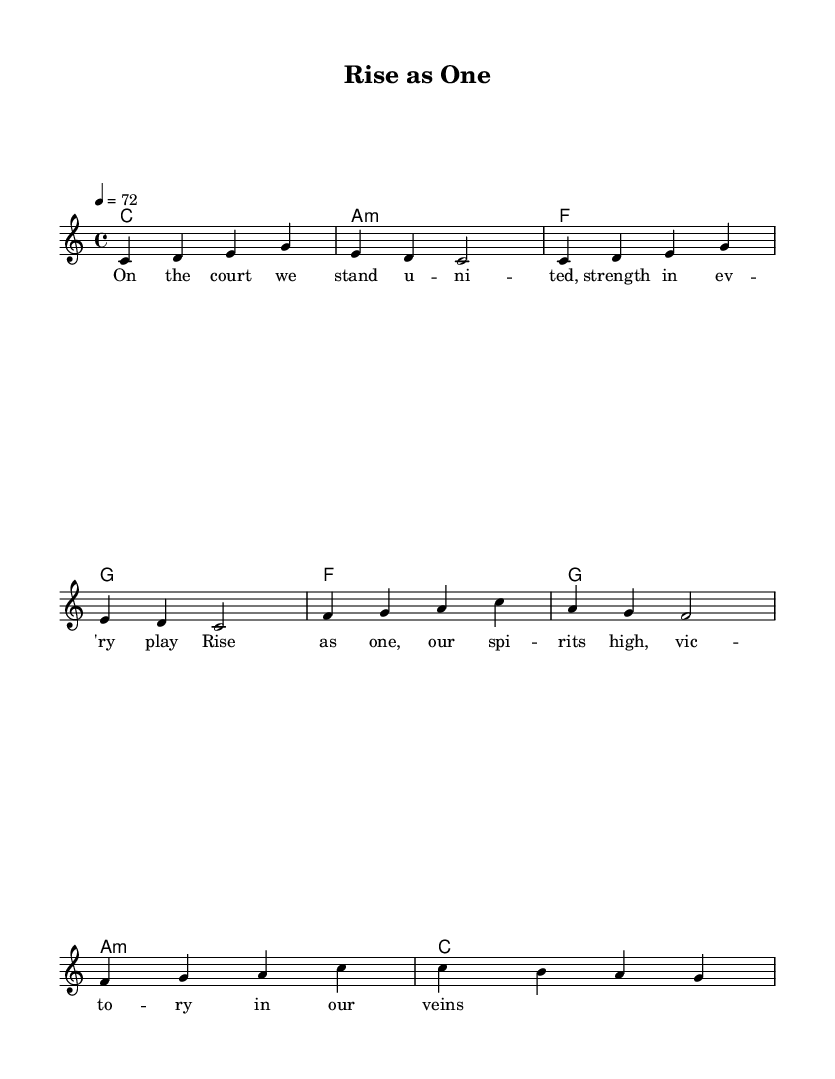What is the key signature of this music? The key signature is indicated at the beginning of the sheet music and shows that it is in C major, which means there are no sharps or flats.
Answer: C major What is the time signature of this music? The time signature is found at the beginning of the sheet music, represented by 4 over 4, meaning there are four beats per measure and the quarter note gets one beat.
Answer: 4/4 What is the tempo marking of this music? The tempo marking can be located near the beginning; it shows that the piece should be played at a speed of 72 beats per minute, indicated by "4 = 72."
Answer: 72 How many measures are in the verse? By counting the individual measures in the "melody" section labeled as verse, there are a total of four measures.
Answer: 4 What is the pattern of the chord progression in the verse? The chord progression is listed under "verseChords" and follows a sequence: C major, A minor, F major, and G major, which provides the harmonic structure for the verse.
Answer: C, A minor, F, G What are the main themes expressed in the lyrics of the chorus? The lyrics of the chorus emphasize unity and victory, captured in the phrases "Rise as one" and "victory in our veins," reflecting the spirit of teamwork and athletic achievement.
Answer: Unity and victory Which musical elements are characteristic of reggae in this anthem? This anthem incorporates a laid-back groove with upbeat rhythms and emphasizes the offbeat, which are fundamental characteristics of reggae music, coupled with themes of inspiration and teamwork.
Answer: Offbeat rhythms and inspirational themes 